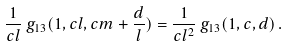<formula> <loc_0><loc_0><loc_500><loc_500>\frac { 1 } { c l } \, g _ { 1 3 } ( 1 , c l , c m + \frac { d } { l } ) = \frac { 1 } { c l ^ { 2 } } \, g _ { 1 3 } ( 1 , c , d ) \, .</formula> 